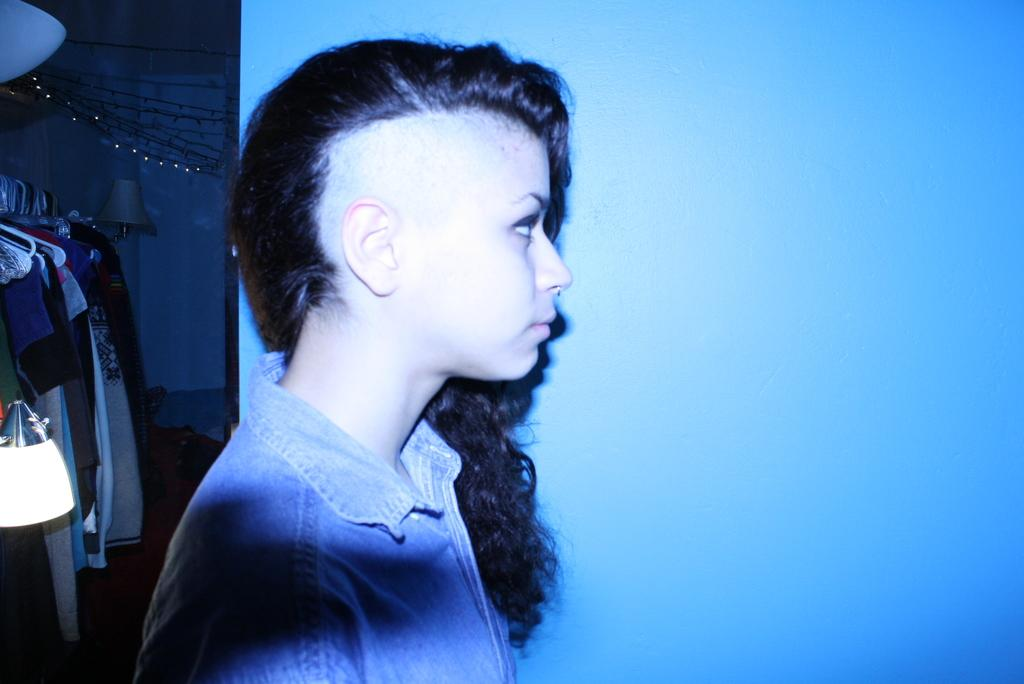What is the main subject in the image? There is a woman standing in the image. What can be seen on the left side of the image? Clothes are hanging on hangers on the left side of the image. Can you describe any objects in the image? There is a lamp in the image. What type of background is visible in the image? There is a wall in the image. What type of bread is being used as a prop on the stage in the image? There is no bread or stage present in the image. How many matches are visible on the wall in the image? There are no matches visible on the wall in the image. 